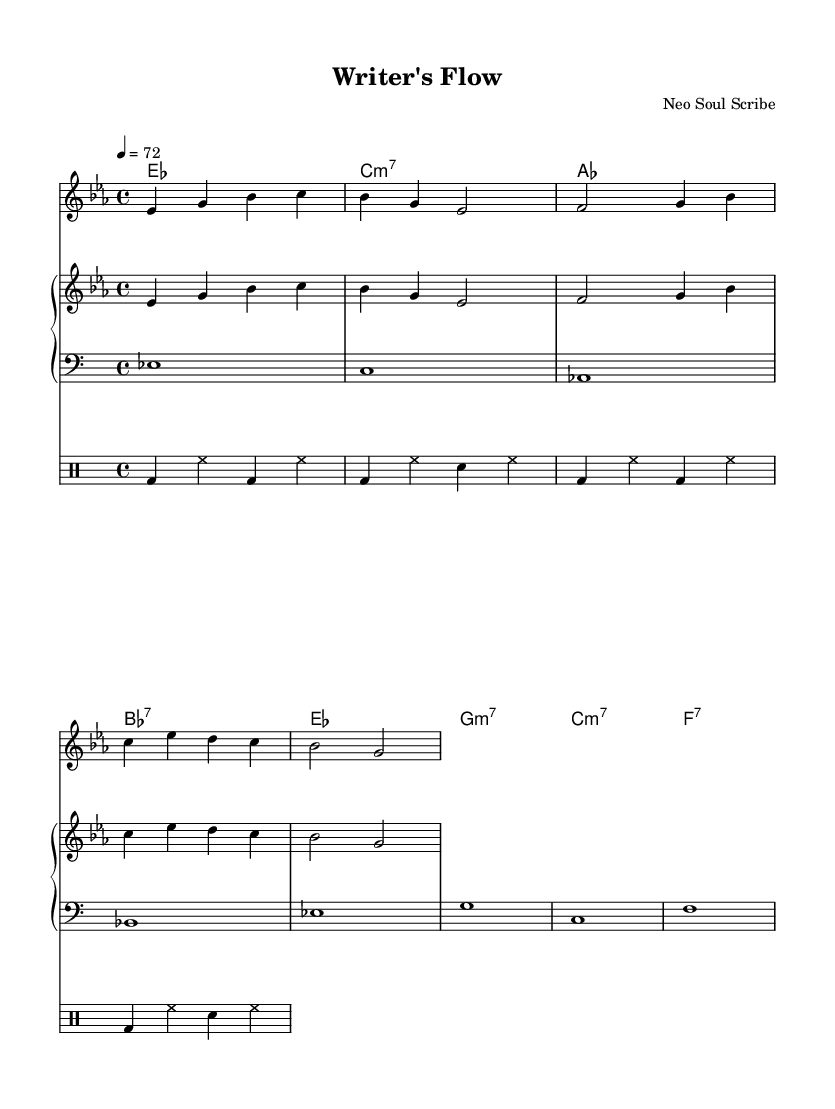What is the key signature of this music? The key signature is E-flat major, which has three flats: B-flat, E-flat, and A-flat. This is determined by looking at the key signature found at the beginning of the music.
Answer: E-flat major What is the time signature of this piece? The time signature is 4/4, which indicates a common meter where there are four beats in each measure and a quarter note gets one beat. This is visible in the notation following the key signature.
Answer: 4/4 What is the tempo marking for the piece? The tempo marking indicates that the piece should be played at 72 beats per minute, which provides a moderate slow tempo for the performance. This is seen at the start of the score under the tempo directive.
Answer: 72 How many measures are in the melody? The melody consists of eight measures, which can be counted by visually observing the vertical bar lines that divide the sections of the music. Each grouping of notes between bar lines counts as one measure.
Answer: Eight measures What chord follows the first measure of the harmony? The chord following the first measure is C minor seven, as indicated by the chord names placed above the melody. This requires looking directly at the chord symbols indicated above the staff.
Answer: C minor seven Which instrument plays the melody? The melody is played by the piano in the upper staff, as indicated in the score with the label "upper." The conventions of the score specify which instrument corresponds to the assigned staff lines.
Answer: Piano Is there a vocal part in the score? Yes, there is a vocal part in the score, which is represented by lyrics aligned above the melody. The presence of a lyrics staff indicates that the piece includes words to be sung with the melody.
Answer: Yes 